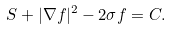<formula> <loc_0><loc_0><loc_500><loc_500>S + | \nabla f | ^ { 2 } - 2 \sigma f = C .</formula> 